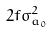Convert formula to latex. <formula><loc_0><loc_0><loc_500><loc_500>2 f \sigma _ { a _ { 0 } } ^ { 2 }</formula> 